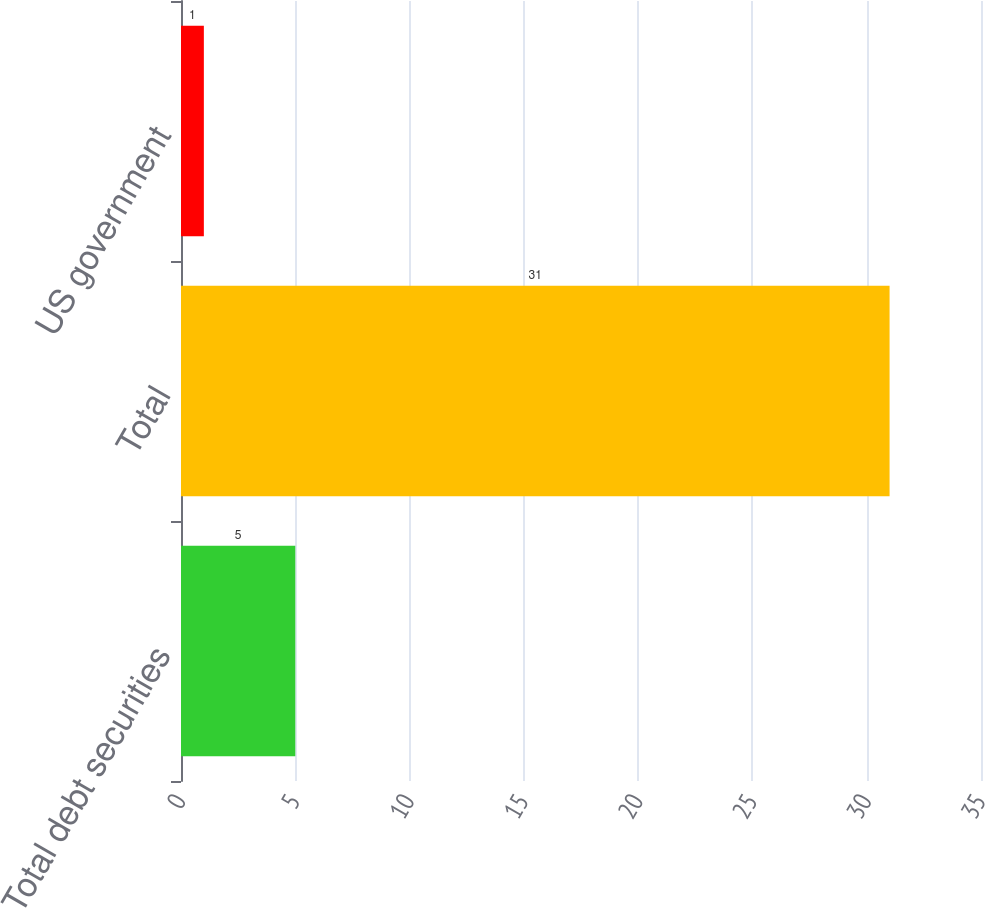Convert chart to OTSL. <chart><loc_0><loc_0><loc_500><loc_500><bar_chart><fcel>Total debt securities<fcel>Total<fcel>US government<nl><fcel>5<fcel>31<fcel>1<nl></chart> 